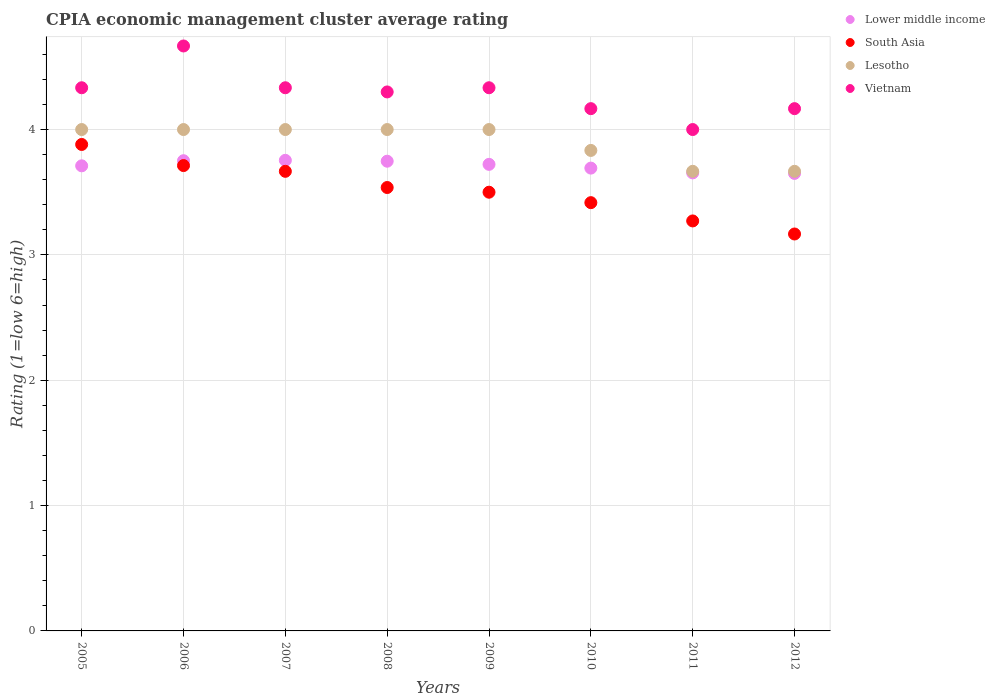How many different coloured dotlines are there?
Offer a terse response. 4. What is the CPIA rating in Lower middle income in 2008?
Make the answer very short. 3.75. Across all years, what is the maximum CPIA rating in Lower middle income?
Ensure brevity in your answer.  3.75. Across all years, what is the minimum CPIA rating in Lower middle income?
Your answer should be compact. 3.65. In which year was the CPIA rating in Lesotho minimum?
Keep it short and to the point. 2011. What is the total CPIA rating in Lesotho in the graph?
Offer a terse response. 31.17. What is the difference between the CPIA rating in South Asia in 2008 and that in 2012?
Provide a short and direct response. 0.37. What is the difference between the CPIA rating in Lower middle income in 2006 and the CPIA rating in South Asia in 2010?
Your answer should be very brief. 0.33. What is the average CPIA rating in Vietnam per year?
Provide a short and direct response. 4.29. In the year 2007, what is the difference between the CPIA rating in South Asia and CPIA rating in Vietnam?
Offer a terse response. -0.67. In how many years, is the CPIA rating in Vietnam greater than 4?
Offer a terse response. 7. What is the ratio of the CPIA rating in Lesotho in 2007 to that in 2010?
Your response must be concise. 1.04. Is the difference between the CPIA rating in South Asia in 2005 and 2009 greater than the difference between the CPIA rating in Vietnam in 2005 and 2009?
Make the answer very short. Yes. What is the difference between the highest and the second highest CPIA rating in Vietnam?
Offer a terse response. 0.33. What is the difference between the highest and the lowest CPIA rating in South Asia?
Your answer should be compact. 0.71. In how many years, is the CPIA rating in Lower middle income greater than the average CPIA rating in Lower middle income taken over all years?
Make the answer very short. 5. Is the sum of the CPIA rating in Lesotho in 2006 and 2009 greater than the maximum CPIA rating in South Asia across all years?
Provide a succinct answer. Yes. Does the CPIA rating in Vietnam monotonically increase over the years?
Your response must be concise. No. Is the CPIA rating in Vietnam strictly less than the CPIA rating in Lesotho over the years?
Offer a very short reply. No. How many dotlines are there?
Ensure brevity in your answer.  4. Are the values on the major ticks of Y-axis written in scientific E-notation?
Provide a succinct answer. No. Does the graph contain any zero values?
Your answer should be compact. No. Does the graph contain grids?
Provide a succinct answer. Yes. How many legend labels are there?
Offer a very short reply. 4. How are the legend labels stacked?
Provide a succinct answer. Vertical. What is the title of the graph?
Keep it short and to the point. CPIA economic management cluster average rating. What is the label or title of the X-axis?
Provide a succinct answer. Years. What is the label or title of the Y-axis?
Ensure brevity in your answer.  Rating (1=low 6=high). What is the Rating (1=low 6=high) of Lower middle income in 2005?
Ensure brevity in your answer.  3.71. What is the Rating (1=low 6=high) in South Asia in 2005?
Offer a terse response. 3.88. What is the Rating (1=low 6=high) in Lesotho in 2005?
Your response must be concise. 4. What is the Rating (1=low 6=high) of Vietnam in 2005?
Keep it short and to the point. 4.33. What is the Rating (1=low 6=high) of Lower middle income in 2006?
Offer a very short reply. 3.75. What is the Rating (1=low 6=high) of South Asia in 2006?
Offer a very short reply. 3.71. What is the Rating (1=low 6=high) of Lesotho in 2006?
Keep it short and to the point. 4. What is the Rating (1=low 6=high) of Vietnam in 2006?
Offer a very short reply. 4.67. What is the Rating (1=low 6=high) in Lower middle income in 2007?
Offer a terse response. 3.75. What is the Rating (1=low 6=high) in South Asia in 2007?
Offer a terse response. 3.67. What is the Rating (1=low 6=high) in Vietnam in 2007?
Your answer should be compact. 4.33. What is the Rating (1=low 6=high) of Lower middle income in 2008?
Ensure brevity in your answer.  3.75. What is the Rating (1=low 6=high) in South Asia in 2008?
Keep it short and to the point. 3.54. What is the Rating (1=low 6=high) of Lower middle income in 2009?
Provide a succinct answer. 3.72. What is the Rating (1=low 6=high) of Lesotho in 2009?
Give a very brief answer. 4. What is the Rating (1=low 6=high) of Vietnam in 2009?
Make the answer very short. 4.33. What is the Rating (1=low 6=high) of Lower middle income in 2010?
Keep it short and to the point. 3.69. What is the Rating (1=low 6=high) of South Asia in 2010?
Ensure brevity in your answer.  3.42. What is the Rating (1=low 6=high) in Lesotho in 2010?
Your answer should be very brief. 3.83. What is the Rating (1=low 6=high) in Vietnam in 2010?
Ensure brevity in your answer.  4.17. What is the Rating (1=low 6=high) of Lower middle income in 2011?
Offer a very short reply. 3.65. What is the Rating (1=low 6=high) in South Asia in 2011?
Your answer should be compact. 3.27. What is the Rating (1=low 6=high) in Lesotho in 2011?
Give a very brief answer. 3.67. What is the Rating (1=low 6=high) in Lower middle income in 2012?
Your answer should be very brief. 3.65. What is the Rating (1=low 6=high) in South Asia in 2012?
Your answer should be compact. 3.17. What is the Rating (1=low 6=high) of Lesotho in 2012?
Offer a very short reply. 3.67. What is the Rating (1=low 6=high) of Vietnam in 2012?
Your answer should be compact. 4.17. Across all years, what is the maximum Rating (1=low 6=high) in Lower middle income?
Keep it short and to the point. 3.75. Across all years, what is the maximum Rating (1=low 6=high) in South Asia?
Provide a short and direct response. 3.88. Across all years, what is the maximum Rating (1=low 6=high) of Lesotho?
Keep it short and to the point. 4. Across all years, what is the maximum Rating (1=low 6=high) in Vietnam?
Offer a very short reply. 4.67. Across all years, what is the minimum Rating (1=low 6=high) in Lower middle income?
Give a very brief answer. 3.65. Across all years, what is the minimum Rating (1=low 6=high) in South Asia?
Your answer should be very brief. 3.17. Across all years, what is the minimum Rating (1=low 6=high) of Lesotho?
Your response must be concise. 3.67. Across all years, what is the minimum Rating (1=low 6=high) in Vietnam?
Your response must be concise. 4. What is the total Rating (1=low 6=high) of Lower middle income in the graph?
Ensure brevity in your answer.  29.68. What is the total Rating (1=low 6=high) in South Asia in the graph?
Ensure brevity in your answer.  28.15. What is the total Rating (1=low 6=high) of Lesotho in the graph?
Provide a succinct answer. 31.17. What is the total Rating (1=low 6=high) of Vietnam in the graph?
Provide a succinct answer. 34.3. What is the difference between the Rating (1=low 6=high) of Lower middle income in 2005 and that in 2006?
Your answer should be very brief. -0.04. What is the difference between the Rating (1=low 6=high) in South Asia in 2005 and that in 2006?
Provide a short and direct response. 0.17. What is the difference between the Rating (1=low 6=high) of Lower middle income in 2005 and that in 2007?
Your answer should be very brief. -0.04. What is the difference between the Rating (1=low 6=high) in South Asia in 2005 and that in 2007?
Make the answer very short. 0.21. What is the difference between the Rating (1=low 6=high) of Lower middle income in 2005 and that in 2008?
Ensure brevity in your answer.  -0.04. What is the difference between the Rating (1=low 6=high) in South Asia in 2005 and that in 2008?
Keep it short and to the point. 0.34. What is the difference between the Rating (1=low 6=high) of Lesotho in 2005 and that in 2008?
Ensure brevity in your answer.  0. What is the difference between the Rating (1=low 6=high) in Vietnam in 2005 and that in 2008?
Offer a very short reply. 0.03. What is the difference between the Rating (1=low 6=high) in Lower middle income in 2005 and that in 2009?
Keep it short and to the point. -0.01. What is the difference between the Rating (1=low 6=high) of South Asia in 2005 and that in 2009?
Provide a succinct answer. 0.38. What is the difference between the Rating (1=low 6=high) in Lower middle income in 2005 and that in 2010?
Offer a very short reply. 0.02. What is the difference between the Rating (1=low 6=high) of South Asia in 2005 and that in 2010?
Provide a succinct answer. 0.46. What is the difference between the Rating (1=low 6=high) of Vietnam in 2005 and that in 2010?
Your response must be concise. 0.17. What is the difference between the Rating (1=low 6=high) of Lower middle income in 2005 and that in 2011?
Your answer should be very brief. 0.06. What is the difference between the Rating (1=low 6=high) of South Asia in 2005 and that in 2011?
Keep it short and to the point. 0.61. What is the difference between the Rating (1=low 6=high) of Lesotho in 2005 and that in 2011?
Provide a succinct answer. 0.33. What is the difference between the Rating (1=low 6=high) of Lower middle income in 2005 and that in 2012?
Give a very brief answer. 0.06. What is the difference between the Rating (1=low 6=high) in Vietnam in 2005 and that in 2012?
Ensure brevity in your answer.  0.17. What is the difference between the Rating (1=low 6=high) of Lower middle income in 2006 and that in 2007?
Provide a succinct answer. -0. What is the difference between the Rating (1=low 6=high) in South Asia in 2006 and that in 2007?
Your response must be concise. 0.05. What is the difference between the Rating (1=low 6=high) of Lower middle income in 2006 and that in 2008?
Ensure brevity in your answer.  0. What is the difference between the Rating (1=low 6=high) in South Asia in 2006 and that in 2008?
Offer a terse response. 0.17. What is the difference between the Rating (1=low 6=high) in Lesotho in 2006 and that in 2008?
Make the answer very short. 0. What is the difference between the Rating (1=low 6=high) of Vietnam in 2006 and that in 2008?
Your answer should be very brief. 0.37. What is the difference between the Rating (1=low 6=high) of Lower middle income in 2006 and that in 2009?
Offer a very short reply. 0.03. What is the difference between the Rating (1=low 6=high) in South Asia in 2006 and that in 2009?
Offer a terse response. 0.21. What is the difference between the Rating (1=low 6=high) in Lesotho in 2006 and that in 2009?
Give a very brief answer. 0. What is the difference between the Rating (1=low 6=high) in Lower middle income in 2006 and that in 2010?
Ensure brevity in your answer.  0.06. What is the difference between the Rating (1=low 6=high) of South Asia in 2006 and that in 2010?
Your answer should be very brief. 0.3. What is the difference between the Rating (1=low 6=high) of Lesotho in 2006 and that in 2010?
Provide a succinct answer. 0.17. What is the difference between the Rating (1=low 6=high) of Vietnam in 2006 and that in 2010?
Your answer should be compact. 0.5. What is the difference between the Rating (1=low 6=high) of Lower middle income in 2006 and that in 2011?
Your response must be concise. 0.1. What is the difference between the Rating (1=low 6=high) in South Asia in 2006 and that in 2011?
Offer a terse response. 0.44. What is the difference between the Rating (1=low 6=high) of Lesotho in 2006 and that in 2011?
Provide a succinct answer. 0.33. What is the difference between the Rating (1=low 6=high) of Vietnam in 2006 and that in 2011?
Make the answer very short. 0.67. What is the difference between the Rating (1=low 6=high) in Lower middle income in 2006 and that in 2012?
Provide a short and direct response. 0.1. What is the difference between the Rating (1=low 6=high) in South Asia in 2006 and that in 2012?
Ensure brevity in your answer.  0.55. What is the difference between the Rating (1=low 6=high) of Vietnam in 2006 and that in 2012?
Provide a short and direct response. 0.5. What is the difference between the Rating (1=low 6=high) in Lower middle income in 2007 and that in 2008?
Provide a succinct answer. 0.01. What is the difference between the Rating (1=low 6=high) in South Asia in 2007 and that in 2008?
Your response must be concise. 0.13. What is the difference between the Rating (1=low 6=high) in Vietnam in 2007 and that in 2008?
Ensure brevity in your answer.  0.03. What is the difference between the Rating (1=low 6=high) in Lower middle income in 2007 and that in 2009?
Your response must be concise. 0.03. What is the difference between the Rating (1=low 6=high) of Lesotho in 2007 and that in 2009?
Provide a succinct answer. 0. What is the difference between the Rating (1=low 6=high) of Lower middle income in 2007 and that in 2010?
Your answer should be very brief. 0.06. What is the difference between the Rating (1=low 6=high) of South Asia in 2007 and that in 2010?
Your answer should be very brief. 0.25. What is the difference between the Rating (1=low 6=high) in Vietnam in 2007 and that in 2010?
Your answer should be compact. 0.17. What is the difference between the Rating (1=low 6=high) of Lower middle income in 2007 and that in 2011?
Your answer should be compact. 0.1. What is the difference between the Rating (1=low 6=high) of South Asia in 2007 and that in 2011?
Offer a terse response. 0.4. What is the difference between the Rating (1=low 6=high) in Lesotho in 2007 and that in 2011?
Ensure brevity in your answer.  0.33. What is the difference between the Rating (1=low 6=high) of Lower middle income in 2007 and that in 2012?
Your answer should be compact. 0.1. What is the difference between the Rating (1=low 6=high) of South Asia in 2007 and that in 2012?
Make the answer very short. 0.5. What is the difference between the Rating (1=low 6=high) of Lesotho in 2007 and that in 2012?
Your answer should be very brief. 0.33. What is the difference between the Rating (1=low 6=high) in Lower middle income in 2008 and that in 2009?
Give a very brief answer. 0.03. What is the difference between the Rating (1=low 6=high) in South Asia in 2008 and that in 2009?
Offer a very short reply. 0.04. What is the difference between the Rating (1=low 6=high) of Lesotho in 2008 and that in 2009?
Give a very brief answer. 0. What is the difference between the Rating (1=low 6=high) of Vietnam in 2008 and that in 2009?
Give a very brief answer. -0.03. What is the difference between the Rating (1=low 6=high) in Lower middle income in 2008 and that in 2010?
Provide a short and direct response. 0.06. What is the difference between the Rating (1=low 6=high) in South Asia in 2008 and that in 2010?
Provide a short and direct response. 0.12. What is the difference between the Rating (1=low 6=high) in Vietnam in 2008 and that in 2010?
Provide a short and direct response. 0.13. What is the difference between the Rating (1=low 6=high) of Lower middle income in 2008 and that in 2011?
Your response must be concise. 0.09. What is the difference between the Rating (1=low 6=high) in South Asia in 2008 and that in 2011?
Offer a very short reply. 0.27. What is the difference between the Rating (1=low 6=high) of Lesotho in 2008 and that in 2011?
Give a very brief answer. 0.33. What is the difference between the Rating (1=low 6=high) of Vietnam in 2008 and that in 2011?
Your response must be concise. 0.3. What is the difference between the Rating (1=low 6=high) in Lower middle income in 2008 and that in 2012?
Give a very brief answer. 0.1. What is the difference between the Rating (1=low 6=high) of South Asia in 2008 and that in 2012?
Keep it short and to the point. 0.37. What is the difference between the Rating (1=low 6=high) of Vietnam in 2008 and that in 2012?
Provide a short and direct response. 0.13. What is the difference between the Rating (1=low 6=high) in Lower middle income in 2009 and that in 2010?
Your response must be concise. 0.03. What is the difference between the Rating (1=low 6=high) of South Asia in 2009 and that in 2010?
Your answer should be very brief. 0.08. What is the difference between the Rating (1=low 6=high) in Lower middle income in 2009 and that in 2011?
Ensure brevity in your answer.  0.07. What is the difference between the Rating (1=low 6=high) in South Asia in 2009 and that in 2011?
Ensure brevity in your answer.  0.23. What is the difference between the Rating (1=low 6=high) in Lower middle income in 2009 and that in 2012?
Ensure brevity in your answer.  0.07. What is the difference between the Rating (1=low 6=high) in South Asia in 2009 and that in 2012?
Make the answer very short. 0.33. What is the difference between the Rating (1=low 6=high) of Vietnam in 2009 and that in 2012?
Provide a succinct answer. 0.17. What is the difference between the Rating (1=low 6=high) in Lower middle income in 2010 and that in 2011?
Offer a terse response. 0.04. What is the difference between the Rating (1=low 6=high) in South Asia in 2010 and that in 2011?
Keep it short and to the point. 0.15. What is the difference between the Rating (1=low 6=high) in Lesotho in 2010 and that in 2011?
Offer a terse response. 0.17. What is the difference between the Rating (1=low 6=high) of Lower middle income in 2010 and that in 2012?
Your response must be concise. 0.04. What is the difference between the Rating (1=low 6=high) in South Asia in 2010 and that in 2012?
Make the answer very short. 0.25. What is the difference between the Rating (1=low 6=high) of Lesotho in 2010 and that in 2012?
Your answer should be compact. 0.17. What is the difference between the Rating (1=low 6=high) of Vietnam in 2010 and that in 2012?
Provide a succinct answer. 0. What is the difference between the Rating (1=low 6=high) in Lower middle income in 2011 and that in 2012?
Keep it short and to the point. 0. What is the difference between the Rating (1=low 6=high) in South Asia in 2011 and that in 2012?
Offer a terse response. 0.1. What is the difference between the Rating (1=low 6=high) in Vietnam in 2011 and that in 2012?
Your answer should be very brief. -0.17. What is the difference between the Rating (1=low 6=high) in Lower middle income in 2005 and the Rating (1=low 6=high) in South Asia in 2006?
Ensure brevity in your answer.  -0. What is the difference between the Rating (1=low 6=high) of Lower middle income in 2005 and the Rating (1=low 6=high) of Lesotho in 2006?
Ensure brevity in your answer.  -0.29. What is the difference between the Rating (1=low 6=high) in Lower middle income in 2005 and the Rating (1=low 6=high) in Vietnam in 2006?
Provide a succinct answer. -0.96. What is the difference between the Rating (1=low 6=high) in South Asia in 2005 and the Rating (1=low 6=high) in Lesotho in 2006?
Provide a short and direct response. -0.12. What is the difference between the Rating (1=low 6=high) of South Asia in 2005 and the Rating (1=low 6=high) of Vietnam in 2006?
Your answer should be compact. -0.79. What is the difference between the Rating (1=low 6=high) in Lesotho in 2005 and the Rating (1=low 6=high) in Vietnam in 2006?
Provide a short and direct response. -0.67. What is the difference between the Rating (1=low 6=high) of Lower middle income in 2005 and the Rating (1=low 6=high) of South Asia in 2007?
Offer a very short reply. 0.04. What is the difference between the Rating (1=low 6=high) in Lower middle income in 2005 and the Rating (1=low 6=high) in Lesotho in 2007?
Your answer should be very brief. -0.29. What is the difference between the Rating (1=low 6=high) of Lower middle income in 2005 and the Rating (1=low 6=high) of Vietnam in 2007?
Give a very brief answer. -0.62. What is the difference between the Rating (1=low 6=high) of South Asia in 2005 and the Rating (1=low 6=high) of Lesotho in 2007?
Ensure brevity in your answer.  -0.12. What is the difference between the Rating (1=low 6=high) in South Asia in 2005 and the Rating (1=low 6=high) in Vietnam in 2007?
Your answer should be compact. -0.45. What is the difference between the Rating (1=low 6=high) of Lower middle income in 2005 and the Rating (1=low 6=high) of South Asia in 2008?
Offer a terse response. 0.17. What is the difference between the Rating (1=low 6=high) of Lower middle income in 2005 and the Rating (1=low 6=high) of Lesotho in 2008?
Give a very brief answer. -0.29. What is the difference between the Rating (1=low 6=high) of Lower middle income in 2005 and the Rating (1=low 6=high) of Vietnam in 2008?
Provide a short and direct response. -0.59. What is the difference between the Rating (1=low 6=high) of South Asia in 2005 and the Rating (1=low 6=high) of Lesotho in 2008?
Keep it short and to the point. -0.12. What is the difference between the Rating (1=low 6=high) in South Asia in 2005 and the Rating (1=low 6=high) in Vietnam in 2008?
Offer a very short reply. -0.42. What is the difference between the Rating (1=low 6=high) in Lesotho in 2005 and the Rating (1=low 6=high) in Vietnam in 2008?
Your answer should be very brief. -0.3. What is the difference between the Rating (1=low 6=high) of Lower middle income in 2005 and the Rating (1=low 6=high) of South Asia in 2009?
Provide a short and direct response. 0.21. What is the difference between the Rating (1=low 6=high) of Lower middle income in 2005 and the Rating (1=low 6=high) of Lesotho in 2009?
Give a very brief answer. -0.29. What is the difference between the Rating (1=low 6=high) in Lower middle income in 2005 and the Rating (1=low 6=high) in Vietnam in 2009?
Keep it short and to the point. -0.62. What is the difference between the Rating (1=low 6=high) of South Asia in 2005 and the Rating (1=low 6=high) of Lesotho in 2009?
Make the answer very short. -0.12. What is the difference between the Rating (1=low 6=high) in South Asia in 2005 and the Rating (1=low 6=high) in Vietnam in 2009?
Make the answer very short. -0.45. What is the difference between the Rating (1=low 6=high) of Lower middle income in 2005 and the Rating (1=low 6=high) of South Asia in 2010?
Ensure brevity in your answer.  0.29. What is the difference between the Rating (1=low 6=high) of Lower middle income in 2005 and the Rating (1=low 6=high) of Lesotho in 2010?
Ensure brevity in your answer.  -0.12. What is the difference between the Rating (1=low 6=high) in Lower middle income in 2005 and the Rating (1=low 6=high) in Vietnam in 2010?
Provide a succinct answer. -0.46. What is the difference between the Rating (1=low 6=high) of South Asia in 2005 and the Rating (1=low 6=high) of Lesotho in 2010?
Your answer should be compact. 0.05. What is the difference between the Rating (1=low 6=high) of South Asia in 2005 and the Rating (1=low 6=high) of Vietnam in 2010?
Provide a short and direct response. -0.29. What is the difference between the Rating (1=low 6=high) in Lesotho in 2005 and the Rating (1=low 6=high) in Vietnam in 2010?
Ensure brevity in your answer.  -0.17. What is the difference between the Rating (1=low 6=high) in Lower middle income in 2005 and the Rating (1=low 6=high) in South Asia in 2011?
Your answer should be compact. 0.44. What is the difference between the Rating (1=low 6=high) of Lower middle income in 2005 and the Rating (1=low 6=high) of Lesotho in 2011?
Ensure brevity in your answer.  0.04. What is the difference between the Rating (1=low 6=high) in Lower middle income in 2005 and the Rating (1=low 6=high) in Vietnam in 2011?
Offer a very short reply. -0.29. What is the difference between the Rating (1=low 6=high) in South Asia in 2005 and the Rating (1=low 6=high) in Lesotho in 2011?
Provide a succinct answer. 0.21. What is the difference between the Rating (1=low 6=high) in South Asia in 2005 and the Rating (1=low 6=high) in Vietnam in 2011?
Your response must be concise. -0.12. What is the difference between the Rating (1=low 6=high) of Lesotho in 2005 and the Rating (1=low 6=high) of Vietnam in 2011?
Your answer should be compact. 0. What is the difference between the Rating (1=low 6=high) of Lower middle income in 2005 and the Rating (1=low 6=high) of South Asia in 2012?
Your answer should be compact. 0.54. What is the difference between the Rating (1=low 6=high) in Lower middle income in 2005 and the Rating (1=low 6=high) in Lesotho in 2012?
Your response must be concise. 0.04. What is the difference between the Rating (1=low 6=high) of Lower middle income in 2005 and the Rating (1=low 6=high) of Vietnam in 2012?
Offer a very short reply. -0.46. What is the difference between the Rating (1=low 6=high) of South Asia in 2005 and the Rating (1=low 6=high) of Lesotho in 2012?
Your answer should be compact. 0.21. What is the difference between the Rating (1=low 6=high) in South Asia in 2005 and the Rating (1=low 6=high) in Vietnam in 2012?
Offer a very short reply. -0.29. What is the difference between the Rating (1=low 6=high) in Lesotho in 2005 and the Rating (1=low 6=high) in Vietnam in 2012?
Make the answer very short. -0.17. What is the difference between the Rating (1=low 6=high) of Lower middle income in 2006 and the Rating (1=low 6=high) of South Asia in 2007?
Give a very brief answer. 0.08. What is the difference between the Rating (1=low 6=high) in Lower middle income in 2006 and the Rating (1=low 6=high) in Lesotho in 2007?
Provide a succinct answer. -0.25. What is the difference between the Rating (1=low 6=high) of Lower middle income in 2006 and the Rating (1=low 6=high) of Vietnam in 2007?
Keep it short and to the point. -0.58. What is the difference between the Rating (1=low 6=high) of South Asia in 2006 and the Rating (1=low 6=high) of Lesotho in 2007?
Your answer should be very brief. -0.29. What is the difference between the Rating (1=low 6=high) in South Asia in 2006 and the Rating (1=low 6=high) in Vietnam in 2007?
Your answer should be compact. -0.62. What is the difference between the Rating (1=low 6=high) of Lesotho in 2006 and the Rating (1=low 6=high) of Vietnam in 2007?
Your answer should be very brief. -0.33. What is the difference between the Rating (1=low 6=high) of Lower middle income in 2006 and the Rating (1=low 6=high) of South Asia in 2008?
Make the answer very short. 0.21. What is the difference between the Rating (1=low 6=high) of Lower middle income in 2006 and the Rating (1=low 6=high) of Lesotho in 2008?
Your response must be concise. -0.25. What is the difference between the Rating (1=low 6=high) in Lower middle income in 2006 and the Rating (1=low 6=high) in Vietnam in 2008?
Keep it short and to the point. -0.55. What is the difference between the Rating (1=low 6=high) of South Asia in 2006 and the Rating (1=low 6=high) of Lesotho in 2008?
Offer a terse response. -0.29. What is the difference between the Rating (1=low 6=high) of South Asia in 2006 and the Rating (1=low 6=high) of Vietnam in 2008?
Keep it short and to the point. -0.59. What is the difference between the Rating (1=low 6=high) in Lesotho in 2006 and the Rating (1=low 6=high) in Vietnam in 2008?
Offer a terse response. -0.3. What is the difference between the Rating (1=low 6=high) in Lower middle income in 2006 and the Rating (1=low 6=high) in South Asia in 2009?
Give a very brief answer. 0.25. What is the difference between the Rating (1=low 6=high) in Lower middle income in 2006 and the Rating (1=low 6=high) in Lesotho in 2009?
Keep it short and to the point. -0.25. What is the difference between the Rating (1=low 6=high) in Lower middle income in 2006 and the Rating (1=low 6=high) in Vietnam in 2009?
Offer a very short reply. -0.58. What is the difference between the Rating (1=low 6=high) of South Asia in 2006 and the Rating (1=low 6=high) of Lesotho in 2009?
Keep it short and to the point. -0.29. What is the difference between the Rating (1=low 6=high) in South Asia in 2006 and the Rating (1=low 6=high) in Vietnam in 2009?
Your answer should be very brief. -0.62. What is the difference between the Rating (1=low 6=high) in Lower middle income in 2006 and the Rating (1=low 6=high) in South Asia in 2010?
Keep it short and to the point. 0.33. What is the difference between the Rating (1=low 6=high) of Lower middle income in 2006 and the Rating (1=low 6=high) of Lesotho in 2010?
Your response must be concise. -0.08. What is the difference between the Rating (1=low 6=high) of Lower middle income in 2006 and the Rating (1=low 6=high) of Vietnam in 2010?
Your answer should be compact. -0.42. What is the difference between the Rating (1=low 6=high) of South Asia in 2006 and the Rating (1=low 6=high) of Lesotho in 2010?
Ensure brevity in your answer.  -0.12. What is the difference between the Rating (1=low 6=high) of South Asia in 2006 and the Rating (1=low 6=high) of Vietnam in 2010?
Provide a succinct answer. -0.45. What is the difference between the Rating (1=low 6=high) of Lesotho in 2006 and the Rating (1=low 6=high) of Vietnam in 2010?
Provide a short and direct response. -0.17. What is the difference between the Rating (1=low 6=high) in Lower middle income in 2006 and the Rating (1=low 6=high) in South Asia in 2011?
Your answer should be compact. 0.48. What is the difference between the Rating (1=low 6=high) in Lower middle income in 2006 and the Rating (1=low 6=high) in Lesotho in 2011?
Make the answer very short. 0.08. What is the difference between the Rating (1=low 6=high) of Lower middle income in 2006 and the Rating (1=low 6=high) of Vietnam in 2011?
Provide a succinct answer. -0.25. What is the difference between the Rating (1=low 6=high) of South Asia in 2006 and the Rating (1=low 6=high) of Lesotho in 2011?
Your answer should be compact. 0.05. What is the difference between the Rating (1=low 6=high) in South Asia in 2006 and the Rating (1=low 6=high) in Vietnam in 2011?
Your response must be concise. -0.29. What is the difference between the Rating (1=low 6=high) of Lesotho in 2006 and the Rating (1=low 6=high) of Vietnam in 2011?
Offer a terse response. 0. What is the difference between the Rating (1=low 6=high) of Lower middle income in 2006 and the Rating (1=low 6=high) of South Asia in 2012?
Offer a terse response. 0.58. What is the difference between the Rating (1=low 6=high) of Lower middle income in 2006 and the Rating (1=low 6=high) of Lesotho in 2012?
Your answer should be compact. 0.08. What is the difference between the Rating (1=low 6=high) in Lower middle income in 2006 and the Rating (1=low 6=high) in Vietnam in 2012?
Your response must be concise. -0.42. What is the difference between the Rating (1=low 6=high) of South Asia in 2006 and the Rating (1=low 6=high) of Lesotho in 2012?
Your answer should be very brief. 0.05. What is the difference between the Rating (1=low 6=high) in South Asia in 2006 and the Rating (1=low 6=high) in Vietnam in 2012?
Ensure brevity in your answer.  -0.45. What is the difference between the Rating (1=low 6=high) in Lower middle income in 2007 and the Rating (1=low 6=high) in South Asia in 2008?
Make the answer very short. 0.22. What is the difference between the Rating (1=low 6=high) of Lower middle income in 2007 and the Rating (1=low 6=high) of Lesotho in 2008?
Provide a succinct answer. -0.25. What is the difference between the Rating (1=low 6=high) of Lower middle income in 2007 and the Rating (1=low 6=high) of Vietnam in 2008?
Ensure brevity in your answer.  -0.55. What is the difference between the Rating (1=low 6=high) in South Asia in 2007 and the Rating (1=low 6=high) in Lesotho in 2008?
Offer a terse response. -0.33. What is the difference between the Rating (1=low 6=high) in South Asia in 2007 and the Rating (1=low 6=high) in Vietnam in 2008?
Provide a succinct answer. -0.63. What is the difference between the Rating (1=low 6=high) in Lesotho in 2007 and the Rating (1=low 6=high) in Vietnam in 2008?
Offer a very short reply. -0.3. What is the difference between the Rating (1=low 6=high) of Lower middle income in 2007 and the Rating (1=low 6=high) of South Asia in 2009?
Provide a short and direct response. 0.25. What is the difference between the Rating (1=low 6=high) of Lower middle income in 2007 and the Rating (1=low 6=high) of Lesotho in 2009?
Make the answer very short. -0.25. What is the difference between the Rating (1=low 6=high) of Lower middle income in 2007 and the Rating (1=low 6=high) of Vietnam in 2009?
Offer a very short reply. -0.58. What is the difference between the Rating (1=low 6=high) of South Asia in 2007 and the Rating (1=low 6=high) of Lesotho in 2009?
Your answer should be compact. -0.33. What is the difference between the Rating (1=low 6=high) in Lower middle income in 2007 and the Rating (1=low 6=high) in South Asia in 2010?
Offer a very short reply. 0.34. What is the difference between the Rating (1=low 6=high) in Lower middle income in 2007 and the Rating (1=low 6=high) in Lesotho in 2010?
Give a very brief answer. -0.08. What is the difference between the Rating (1=low 6=high) of Lower middle income in 2007 and the Rating (1=low 6=high) of Vietnam in 2010?
Your answer should be very brief. -0.41. What is the difference between the Rating (1=low 6=high) in South Asia in 2007 and the Rating (1=low 6=high) in Lesotho in 2010?
Provide a succinct answer. -0.17. What is the difference between the Rating (1=low 6=high) of Lower middle income in 2007 and the Rating (1=low 6=high) of South Asia in 2011?
Your answer should be compact. 0.48. What is the difference between the Rating (1=low 6=high) in Lower middle income in 2007 and the Rating (1=low 6=high) in Lesotho in 2011?
Give a very brief answer. 0.09. What is the difference between the Rating (1=low 6=high) in Lower middle income in 2007 and the Rating (1=low 6=high) in Vietnam in 2011?
Keep it short and to the point. -0.25. What is the difference between the Rating (1=low 6=high) in South Asia in 2007 and the Rating (1=low 6=high) in Lesotho in 2011?
Provide a short and direct response. 0. What is the difference between the Rating (1=low 6=high) of South Asia in 2007 and the Rating (1=low 6=high) of Vietnam in 2011?
Make the answer very short. -0.33. What is the difference between the Rating (1=low 6=high) in Lesotho in 2007 and the Rating (1=low 6=high) in Vietnam in 2011?
Ensure brevity in your answer.  0. What is the difference between the Rating (1=low 6=high) in Lower middle income in 2007 and the Rating (1=low 6=high) in South Asia in 2012?
Your answer should be compact. 0.59. What is the difference between the Rating (1=low 6=high) in Lower middle income in 2007 and the Rating (1=low 6=high) in Lesotho in 2012?
Ensure brevity in your answer.  0.09. What is the difference between the Rating (1=low 6=high) of Lower middle income in 2007 and the Rating (1=low 6=high) of Vietnam in 2012?
Keep it short and to the point. -0.41. What is the difference between the Rating (1=low 6=high) in South Asia in 2007 and the Rating (1=low 6=high) in Lesotho in 2012?
Give a very brief answer. 0. What is the difference between the Rating (1=low 6=high) of Lower middle income in 2008 and the Rating (1=low 6=high) of South Asia in 2009?
Keep it short and to the point. 0.25. What is the difference between the Rating (1=low 6=high) of Lower middle income in 2008 and the Rating (1=low 6=high) of Lesotho in 2009?
Your answer should be very brief. -0.25. What is the difference between the Rating (1=low 6=high) in Lower middle income in 2008 and the Rating (1=low 6=high) in Vietnam in 2009?
Offer a terse response. -0.59. What is the difference between the Rating (1=low 6=high) in South Asia in 2008 and the Rating (1=low 6=high) in Lesotho in 2009?
Give a very brief answer. -0.46. What is the difference between the Rating (1=low 6=high) in South Asia in 2008 and the Rating (1=low 6=high) in Vietnam in 2009?
Keep it short and to the point. -0.8. What is the difference between the Rating (1=low 6=high) of Lower middle income in 2008 and the Rating (1=low 6=high) of South Asia in 2010?
Provide a succinct answer. 0.33. What is the difference between the Rating (1=low 6=high) of Lower middle income in 2008 and the Rating (1=low 6=high) of Lesotho in 2010?
Ensure brevity in your answer.  -0.09. What is the difference between the Rating (1=low 6=high) of Lower middle income in 2008 and the Rating (1=low 6=high) of Vietnam in 2010?
Your answer should be very brief. -0.42. What is the difference between the Rating (1=low 6=high) of South Asia in 2008 and the Rating (1=low 6=high) of Lesotho in 2010?
Keep it short and to the point. -0.3. What is the difference between the Rating (1=low 6=high) in South Asia in 2008 and the Rating (1=low 6=high) in Vietnam in 2010?
Give a very brief answer. -0.63. What is the difference between the Rating (1=low 6=high) in Lower middle income in 2008 and the Rating (1=low 6=high) in South Asia in 2011?
Offer a very short reply. 0.48. What is the difference between the Rating (1=low 6=high) in Lower middle income in 2008 and the Rating (1=low 6=high) in Lesotho in 2011?
Your answer should be compact. 0.08. What is the difference between the Rating (1=low 6=high) of Lower middle income in 2008 and the Rating (1=low 6=high) of Vietnam in 2011?
Provide a succinct answer. -0.25. What is the difference between the Rating (1=low 6=high) of South Asia in 2008 and the Rating (1=low 6=high) of Lesotho in 2011?
Offer a very short reply. -0.13. What is the difference between the Rating (1=low 6=high) of South Asia in 2008 and the Rating (1=low 6=high) of Vietnam in 2011?
Offer a very short reply. -0.46. What is the difference between the Rating (1=low 6=high) of Lesotho in 2008 and the Rating (1=low 6=high) of Vietnam in 2011?
Ensure brevity in your answer.  0. What is the difference between the Rating (1=low 6=high) in Lower middle income in 2008 and the Rating (1=low 6=high) in South Asia in 2012?
Keep it short and to the point. 0.58. What is the difference between the Rating (1=low 6=high) in Lower middle income in 2008 and the Rating (1=low 6=high) in Lesotho in 2012?
Your answer should be very brief. 0.08. What is the difference between the Rating (1=low 6=high) in Lower middle income in 2008 and the Rating (1=low 6=high) in Vietnam in 2012?
Offer a very short reply. -0.42. What is the difference between the Rating (1=low 6=high) of South Asia in 2008 and the Rating (1=low 6=high) of Lesotho in 2012?
Provide a succinct answer. -0.13. What is the difference between the Rating (1=low 6=high) in South Asia in 2008 and the Rating (1=low 6=high) in Vietnam in 2012?
Your answer should be compact. -0.63. What is the difference between the Rating (1=low 6=high) of Lower middle income in 2009 and the Rating (1=low 6=high) of South Asia in 2010?
Provide a succinct answer. 0.31. What is the difference between the Rating (1=low 6=high) in Lower middle income in 2009 and the Rating (1=low 6=high) in Lesotho in 2010?
Your answer should be very brief. -0.11. What is the difference between the Rating (1=low 6=high) of Lower middle income in 2009 and the Rating (1=low 6=high) of Vietnam in 2010?
Provide a short and direct response. -0.44. What is the difference between the Rating (1=low 6=high) in Lesotho in 2009 and the Rating (1=low 6=high) in Vietnam in 2010?
Your answer should be very brief. -0.17. What is the difference between the Rating (1=low 6=high) of Lower middle income in 2009 and the Rating (1=low 6=high) of South Asia in 2011?
Your answer should be compact. 0.45. What is the difference between the Rating (1=low 6=high) of Lower middle income in 2009 and the Rating (1=low 6=high) of Lesotho in 2011?
Offer a very short reply. 0.06. What is the difference between the Rating (1=low 6=high) in Lower middle income in 2009 and the Rating (1=low 6=high) in Vietnam in 2011?
Your response must be concise. -0.28. What is the difference between the Rating (1=low 6=high) of South Asia in 2009 and the Rating (1=low 6=high) of Lesotho in 2011?
Give a very brief answer. -0.17. What is the difference between the Rating (1=low 6=high) of Lower middle income in 2009 and the Rating (1=low 6=high) of South Asia in 2012?
Your answer should be very brief. 0.56. What is the difference between the Rating (1=low 6=high) in Lower middle income in 2009 and the Rating (1=low 6=high) in Lesotho in 2012?
Provide a short and direct response. 0.06. What is the difference between the Rating (1=low 6=high) in Lower middle income in 2009 and the Rating (1=low 6=high) in Vietnam in 2012?
Give a very brief answer. -0.44. What is the difference between the Rating (1=low 6=high) in South Asia in 2009 and the Rating (1=low 6=high) in Vietnam in 2012?
Provide a succinct answer. -0.67. What is the difference between the Rating (1=low 6=high) of Lesotho in 2009 and the Rating (1=low 6=high) of Vietnam in 2012?
Provide a short and direct response. -0.17. What is the difference between the Rating (1=low 6=high) in Lower middle income in 2010 and the Rating (1=low 6=high) in South Asia in 2011?
Your answer should be compact. 0.42. What is the difference between the Rating (1=low 6=high) of Lower middle income in 2010 and the Rating (1=low 6=high) of Lesotho in 2011?
Make the answer very short. 0.03. What is the difference between the Rating (1=low 6=high) in Lower middle income in 2010 and the Rating (1=low 6=high) in Vietnam in 2011?
Your answer should be very brief. -0.31. What is the difference between the Rating (1=low 6=high) in South Asia in 2010 and the Rating (1=low 6=high) in Lesotho in 2011?
Provide a short and direct response. -0.25. What is the difference between the Rating (1=low 6=high) of South Asia in 2010 and the Rating (1=low 6=high) of Vietnam in 2011?
Your response must be concise. -0.58. What is the difference between the Rating (1=low 6=high) of Lower middle income in 2010 and the Rating (1=low 6=high) of South Asia in 2012?
Offer a terse response. 0.53. What is the difference between the Rating (1=low 6=high) in Lower middle income in 2010 and the Rating (1=low 6=high) in Lesotho in 2012?
Give a very brief answer. 0.03. What is the difference between the Rating (1=low 6=high) in Lower middle income in 2010 and the Rating (1=low 6=high) in Vietnam in 2012?
Your answer should be very brief. -0.47. What is the difference between the Rating (1=low 6=high) in South Asia in 2010 and the Rating (1=low 6=high) in Vietnam in 2012?
Keep it short and to the point. -0.75. What is the difference between the Rating (1=low 6=high) of Lower middle income in 2011 and the Rating (1=low 6=high) of South Asia in 2012?
Keep it short and to the point. 0.49. What is the difference between the Rating (1=low 6=high) of Lower middle income in 2011 and the Rating (1=low 6=high) of Lesotho in 2012?
Provide a short and direct response. -0.01. What is the difference between the Rating (1=low 6=high) of Lower middle income in 2011 and the Rating (1=low 6=high) of Vietnam in 2012?
Make the answer very short. -0.51. What is the difference between the Rating (1=low 6=high) in South Asia in 2011 and the Rating (1=low 6=high) in Lesotho in 2012?
Offer a very short reply. -0.4. What is the difference between the Rating (1=low 6=high) in South Asia in 2011 and the Rating (1=low 6=high) in Vietnam in 2012?
Your response must be concise. -0.9. What is the average Rating (1=low 6=high) of Lower middle income per year?
Provide a short and direct response. 3.71. What is the average Rating (1=low 6=high) of South Asia per year?
Provide a succinct answer. 3.52. What is the average Rating (1=low 6=high) in Lesotho per year?
Your response must be concise. 3.9. What is the average Rating (1=low 6=high) of Vietnam per year?
Give a very brief answer. 4.29. In the year 2005, what is the difference between the Rating (1=low 6=high) of Lower middle income and Rating (1=low 6=high) of South Asia?
Provide a short and direct response. -0.17. In the year 2005, what is the difference between the Rating (1=low 6=high) in Lower middle income and Rating (1=low 6=high) in Lesotho?
Ensure brevity in your answer.  -0.29. In the year 2005, what is the difference between the Rating (1=low 6=high) in Lower middle income and Rating (1=low 6=high) in Vietnam?
Offer a very short reply. -0.62. In the year 2005, what is the difference between the Rating (1=low 6=high) of South Asia and Rating (1=low 6=high) of Lesotho?
Ensure brevity in your answer.  -0.12. In the year 2005, what is the difference between the Rating (1=low 6=high) of South Asia and Rating (1=low 6=high) of Vietnam?
Your answer should be compact. -0.45. In the year 2005, what is the difference between the Rating (1=low 6=high) of Lesotho and Rating (1=low 6=high) of Vietnam?
Provide a succinct answer. -0.33. In the year 2006, what is the difference between the Rating (1=low 6=high) in Lower middle income and Rating (1=low 6=high) in South Asia?
Offer a very short reply. 0.04. In the year 2006, what is the difference between the Rating (1=low 6=high) of Lower middle income and Rating (1=low 6=high) of Lesotho?
Your response must be concise. -0.25. In the year 2006, what is the difference between the Rating (1=low 6=high) of Lower middle income and Rating (1=low 6=high) of Vietnam?
Provide a short and direct response. -0.92. In the year 2006, what is the difference between the Rating (1=low 6=high) of South Asia and Rating (1=low 6=high) of Lesotho?
Your response must be concise. -0.29. In the year 2006, what is the difference between the Rating (1=low 6=high) in South Asia and Rating (1=low 6=high) in Vietnam?
Make the answer very short. -0.95. In the year 2007, what is the difference between the Rating (1=low 6=high) of Lower middle income and Rating (1=low 6=high) of South Asia?
Make the answer very short. 0.09. In the year 2007, what is the difference between the Rating (1=low 6=high) of Lower middle income and Rating (1=low 6=high) of Lesotho?
Make the answer very short. -0.25. In the year 2007, what is the difference between the Rating (1=low 6=high) of Lower middle income and Rating (1=low 6=high) of Vietnam?
Ensure brevity in your answer.  -0.58. In the year 2007, what is the difference between the Rating (1=low 6=high) of South Asia and Rating (1=low 6=high) of Lesotho?
Keep it short and to the point. -0.33. In the year 2007, what is the difference between the Rating (1=low 6=high) of South Asia and Rating (1=low 6=high) of Vietnam?
Ensure brevity in your answer.  -0.67. In the year 2007, what is the difference between the Rating (1=low 6=high) of Lesotho and Rating (1=low 6=high) of Vietnam?
Your answer should be very brief. -0.33. In the year 2008, what is the difference between the Rating (1=low 6=high) of Lower middle income and Rating (1=low 6=high) of South Asia?
Your response must be concise. 0.21. In the year 2008, what is the difference between the Rating (1=low 6=high) in Lower middle income and Rating (1=low 6=high) in Lesotho?
Provide a short and direct response. -0.25. In the year 2008, what is the difference between the Rating (1=low 6=high) of Lower middle income and Rating (1=low 6=high) of Vietnam?
Provide a succinct answer. -0.55. In the year 2008, what is the difference between the Rating (1=low 6=high) in South Asia and Rating (1=low 6=high) in Lesotho?
Your answer should be very brief. -0.46. In the year 2008, what is the difference between the Rating (1=low 6=high) of South Asia and Rating (1=low 6=high) of Vietnam?
Keep it short and to the point. -0.76. In the year 2008, what is the difference between the Rating (1=low 6=high) in Lesotho and Rating (1=low 6=high) in Vietnam?
Give a very brief answer. -0.3. In the year 2009, what is the difference between the Rating (1=low 6=high) in Lower middle income and Rating (1=low 6=high) in South Asia?
Your response must be concise. 0.22. In the year 2009, what is the difference between the Rating (1=low 6=high) of Lower middle income and Rating (1=low 6=high) of Lesotho?
Give a very brief answer. -0.28. In the year 2009, what is the difference between the Rating (1=low 6=high) in Lower middle income and Rating (1=low 6=high) in Vietnam?
Give a very brief answer. -0.61. In the year 2010, what is the difference between the Rating (1=low 6=high) of Lower middle income and Rating (1=low 6=high) of South Asia?
Your response must be concise. 0.28. In the year 2010, what is the difference between the Rating (1=low 6=high) in Lower middle income and Rating (1=low 6=high) in Lesotho?
Your answer should be very brief. -0.14. In the year 2010, what is the difference between the Rating (1=low 6=high) in Lower middle income and Rating (1=low 6=high) in Vietnam?
Ensure brevity in your answer.  -0.47. In the year 2010, what is the difference between the Rating (1=low 6=high) of South Asia and Rating (1=low 6=high) of Lesotho?
Keep it short and to the point. -0.42. In the year 2010, what is the difference between the Rating (1=low 6=high) of South Asia and Rating (1=low 6=high) of Vietnam?
Provide a short and direct response. -0.75. In the year 2011, what is the difference between the Rating (1=low 6=high) of Lower middle income and Rating (1=low 6=high) of South Asia?
Provide a short and direct response. 0.38. In the year 2011, what is the difference between the Rating (1=low 6=high) of Lower middle income and Rating (1=low 6=high) of Lesotho?
Provide a short and direct response. -0.01. In the year 2011, what is the difference between the Rating (1=low 6=high) of Lower middle income and Rating (1=low 6=high) of Vietnam?
Your answer should be very brief. -0.35. In the year 2011, what is the difference between the Rating (1=low 6=high) in South Asia and Rating (1=low 6=high) in Lesotho?
Provide a succinct answer. -0.4. In the year 2011, what is the difference between the Rating (1=low 6=high) in South Asia and Rating (1=low 6=high) in Vietnam?
Make the answer very short. -0.73. In the year 2011, what is the difference between the Rating (1=low 6=high) of Lesotho and Rating (1=low 6=high) of Vietnam?
Give a very brief answer. -0.33. In the year 2012, what is the difference between the Rating (1=low 6=high) of Lower middle income and Rating (1=low 6=high) of South Asia?
Ensure brevity in your answer.  0.48. In the year 2012, what is the difference between the Rating (1=low 6=high) of Lower middle income and Rating (1=low 6=high) of Lesotho?
Your answer should be very brief. -0.02. In the year 2012, what is the difference between the Rating (1=low 6=high) of Lower middle income and Rating (1=low 6=high) of Vietnam?
Your response must be concise. -0.52. In the year 2012, what is the difference between the Rating (1=low 6=high) in South Asia and Rating (1=low 6=high) in Lesotho?
Provide a succinct answer. -0.5. In the year 2012, what is the difference between the Rating (1=low 6=high) in Lesotho and Rating (1=low 6=high) in Vietnam?
Give a very brief answer. -0.5. What is the ratio of the Rating (1=low 6=high) of South Asia in 2005 to that in 2006?
Offer a very short reply. 1.05. What is the ratio of the Rating (1=low 6=high) of Lesotho in 2005 to that in 2006?
Your answer should be compact. 1. What is the ratio of the Rating (1=low 6=high) in Lower middle income in 2005 to that in 2007?
Provide a short and direct response. 0.99. What is the ratio of the Rating (1=low 6=high) in South Asia in 2005 to that in 2007?
Provide a short and direct response. 1.06. What is the ratio of the Rating (1=low 6=high) in Lesotho in 2005 to that in 2007?
Give a very brief answer. 1. What is the ratio of the Rating (1=low 6=high) in Lower middle income in 2005 to that in 2008?
Your answer should be very brief. 0.99. What is the ratio of the Rating (1=low 6=high) in South Asia in 2005 to that in 2008?
Give a very brief answer. 1.1. What is the ratio of the Rating (1=low 6=high) of Vietnam in 2005 to that in 2008?
Your answer should be very brief. 1.01. What is the ratio of the Rating (1=low 6=high) in Lower middle income in 2005 to that in 2009?
Provide a succinct answer. 1. What is the ratio of the Rating (1=low 6=high) in South Asia in 2005 to that in 2009?
Keep it short and to the point. 1.11. What is the ratio of the Rating (1=low 6=high) in Lesotho in 2005 to that in 2009?
Provide a succinct answer. 1. What is the ratio of the Rating (1=low 6=high) in Vietnam in 2005 to that in 2009?
Provide a short and direct response. 1. What is the ratio of the Rating (1=low 6=high) of Lower middle income in 2005 to that in 2010?
Ensure brevity in your answer.  1. What is the ratio of the Rating (1=low 6=high) of South Asia in 2005 to that in 2010?
Provide a short and direct response. 1.14. What is the ratio of the Rating (1=low 6=high) in Lesotho in 2005 to that in 2010?
Provide a short and direct response. 1.04. What is the ratio of the Rating (1=low 6=high) in Vietnam in 2005 to that in 2010?
Provide a succinct answer. 1.04. What is the ratio of the Rating (1=low 6=high) in Lower middle income in 2005 to that in 2011?
Ensure brevity in your answer.  1.02. What is the ratio of the Rating (1=low 6=high) of South Asia in 2005 to that in 2011?
Your answer should be very brief. 1.19. What is the ratio of the Rating (1=low 6=high) in Vietnam in 2005 to that in 2011?
Your answer should be compact. 1.08. What is the ratio of the Rating (1=low 6=high) of Lower middle income in 2005 to that in 2012?
Keep it short and to the point. 1.02. What is the ratio of the Rating (1=low 6=high) in South Asia in 2005 to that in 2012?
Give a very brief answer. 1.23. What is the ratio of the Rating (1=low 6=high) of Lesotho in 2005 to that in 2012?
Offer a very short reply. 1.09. What is the ratio of the Rating (1=low 6=high) in Lower middle income in 2006 to that in 2007?
Provide a short and direct response. 1. What is the ratio of the Rating (1=low 6=high) in South Asia in 2006 to that in 2007?
Your response must be concise. 1.01. What is the ratio of the Rating (1=low 6=high) of Lesotho in 2006 to that in 2007?
Offer a terse response. 1. What is the ratio of the Rating (1=low 6=high) of South Asia in 2006 to that in 2008?
Provide a succinct answer. 1.05. What is the ratio of the Rating (1=low 6=high) in Vietnam in 2006 to that in 2008?
Keep it short and to the point. 1.09. What is the ratio of the Rating (1=low 6=high) of South Asia in 2006 to that in 2009?
Your answer should be very brief. 1.06. What is the ratio of the Rating (1=low 6=high) in Lower middle income in 2006 to that in 2010?
Your answer should be very brief. 1.02. What is the ratio of the Rating (1=low 6=high) of South Asia in 2006 to that in 2010?
Your answer should be compact. 1.09. What is the ratio of the Rating (1=low 6=high) in Lesotho in 2006 to that in 2010?
Your answer should be very brief. 1.04. What is the ratio of the Rating (1=low 6=high) of Vietnam in 2006 to that in 2010?
Make the answer very short. 1.12. What is the ratio of the Rating (1=low 6=high) of Lower middle income in 2006 to that in 2011?
Provide a succinct answer. 1.03. What is the ratio of the Rating (1=low 6=high) of South Asia in 2006 to that in 2011?
Your response must be concise. 1.14. What is the ratio of the Rating (1=low 6=high) of Vietnam in 2006 to that in 2011?
Your answer should be very brief. 1.17. What is the ratio of the Rating (1=low 6=high) of Lower middle income in 2006 to that in 2012?
Offer a very short reply. 1.03. What is the ratio of the Rating (1=low 6=high) in South Asia in 2006 to that in 2012?
Provide a short and direct response. 1.17. What is the ratio of the Rating (1=low 6=high) of Vietnam in 2006 to that in 2012?
Provide a succinct answer. 1.12. What is the ratio of the Rating (1=low 6=high) in South Asia in 2007 to that in 2008?
Make the answer very short. 1.04. What is the ratio of the Rating (1=low 6=high) of Lesotho in 2007 to that in 2008?
Provide a short and direct response. 1. What is the ratio of the Rating (1=low 6=high) of Lower middle income in 2007 to that in 2009?
Ensure brevity in your answer.  1.01. What is the ratio of the Rating (1=low 6=high) in South Asia in 2007 to that in 2009?
Give a very brief answer. 1.05. What is the ratio of the Rating (1=low 6=high) of Vietnam in 2007 to that in 2009?
Keep it short and to the point. 1. What is the ratio of the Rating (1=low 6=high) of Lower middle income in 2007 to that in 2010?
Your answer should be compact. 1.02. What is the ratio of the Rating (1=low 6=high) in South Asia in 2007 to that in 2010?
Your response must be concise. 1.07. What is the ratio of the Rating (1=low 6=high) in Lesotho in 2007 to that in 2010?
Your answer should be very brief. 1.04. What is the ratio of the Rating (1=low 6=high) of Lower middle income in 2007 to that in 2011?
Ensure brevity in your answer.  1.03. What is the ratio of the Rating (1=low 6=high) in South Asia in 2007 to that in 2011?
Your answer should be compact. 1.12. What is the ratio of the Rating (1=low 6=high) in Lesotho in 2007 to that in 2011?
Provide a short and direct response. 1.09. What is the ratio of the Rating (1=low 6=high) of Lower middle income in 2007 to that in 2012?
Offer a terse response. 1.03. What is the ratio of the Rating (1=low 6=high) in South Asia in 2007 to that in 2012?
Give a very brief answer. 1.16. What is the ratio of the Rating (1=low 6=high) in Lesotho in 2007 to that in 2012?
Give a very brief answer. 1.09. What is the ratio of the Rating (1=low 6=high) of Lower middle income in 2008 to that in 2009?
Ensure brevity in your answer.  1.01. What is the ratio of the Rating (1=low 6=high) of South Asia in 2008 to that in 2009?
Provide a short and direct response. 1.01. What is the ratio of the Rating (1=low 6=high) of Lower middle income in 2008 to that in 2010?
Provide a succinct answer. 1.01. What is the ratio of the Rating (1=low 6=high) of South Asia in 2008 to that in 2010?
Offer a terse response. 1.04. What is the ratio of the Rating (1=low 6=high) of Lesotho in 2008 to that in 2010?
Give a very brief answer. 1.04. What is the ratio of the Rating (1=low 6=high) of Vietnam in 2008 to that in 2010?
Your response must be concise. 1.03. What is the ratio of the Rating (1=low 6=high) in Lower middle income in 2008 to that in 2011?
Offer a very short reply. 1.03. What is the ratio of the Rating (1=low 6=high) in South Asia in 2008 to that in 2011?
Offer a terse response. 1.08. What is the ratio of the Rating (1=low 6=high) in Vietnam in 2008 to that in 2011?
Offer a terse response. 1.07. What is the ratio of the Rating (1=low 6=high) in Lower middle income in 2008 to that in 2012?
Ensure brevity in your answer.  1.03. What is the ratio of the Rating (1=low 6=high) of South Asia in 2008 to that in 2012?
Your answer should be compact. 1.12. What is the ratio of the Rating (1=low 6=high) in Vietnam in 2008 to that in 2012?
Provide a succinct answer. 1.03. What is the ratio of the Rating (1=low 6=high) of Lower middle income in 2009 to that in 2010?
Ensure brevity in your answer.  1.01. What is the ratio of the Rating (1=low 6=high) of South Asia in 2009 to that in 2010?
Give a very brief answer. 1.02. What is the ratio of the Rating (1=low 6=high) of Lesotho in 2009 to that in 2010?
Provide a succinct answer. 1.04. What is the ratio of the Rating (1=low 6=high) in Lower middle income in 2009 to that in 2011?
Your answer should be compact. 1.02. What is the ratio of the Rating (1=low 6=high) in South Asia in 2009 to that in 2011?
Provide a short and direct response. 1.07. What is the ratio of the Rating (1=low 6=high) in Vietnam in 2009 to that in 2011?
Offer a terse response. 1.08. What is the ratio of the Rating (1=low 6=high) of Lower middle income in 2009 to that in 2012?
Ensure brevity in your answer.  1.02. What is the ratio of the Rating (1=low 6=high) of South Asia in 2009 to that in 2012?
Provide a succinct answer. 1.11. What is the ratio of the Rating (1=low 6=high) in Vietnam in 2009 to that in 2012?
Offer a very short reply. 1.04. What is the ratio of the Rating (1=low 6=high) in Lower middle income in 2010 to that in 2011?
Your answer should be very brief. 1.01. What is the ratio of the Rating (1=low 6=high) of South Asia in 2010 to that in 2011?
Your answer should be very brief. 1.04. What is the ratio of the Rating (1=low 6=high) in Lesotho in 2010 to that in 2011?
Keep it short and to the point. 1.05. What is the ratio of the Rating (1=low 6=high) of Vietnam in 2010 to that in 2011?
Give a very brief answer. 1.04. What is the ratio of the Rating (1=low 6=high) in Lower middle income in 2010 to that in 2012?
Your answer should be very brief. 1.01. What is the ratio of the Rating (1=low 6=high) in South Asia in 2010 to that in 2012?
Your answer should be very brief. 1.08. What is the ratio of the Rating (1=low 6=high) of Lesotho in 2010 to that in 2012?
Give a very brief answer. 1.05. What is the ratio of the Rating (1=low 6=high) of Vietnam in 2010 to that in 2012?
Keep it short and to the point. 1. What is the ratio of the Rating (1=low 6=high) in South Asia in 2011 to that in 2012?
Ensure brevity in your answer.  1.03. What is the ratio of the Rating (1=low 6=high) of Vietnam in 2011 to that in 2012?
Offer a terse response. 0.96. What is the difference between the highest and the second highest Rating (1=low 6=high) of Lower middle income?
Give a very brief answer. 0. What is the difference between the highest and the second highest Rating (1=low 6=high) in South Asia?
Make the answer very short. 0.17. What is the difference between the highest and the lowest Rating (1=low 6=high) in Lower middle income?
Ensure brevity in your answer.  0.1. What is the difference between the highest and the lowest Rating (1=low 6=high) in Lesotho?
Offer a very short reply. 0.33. 